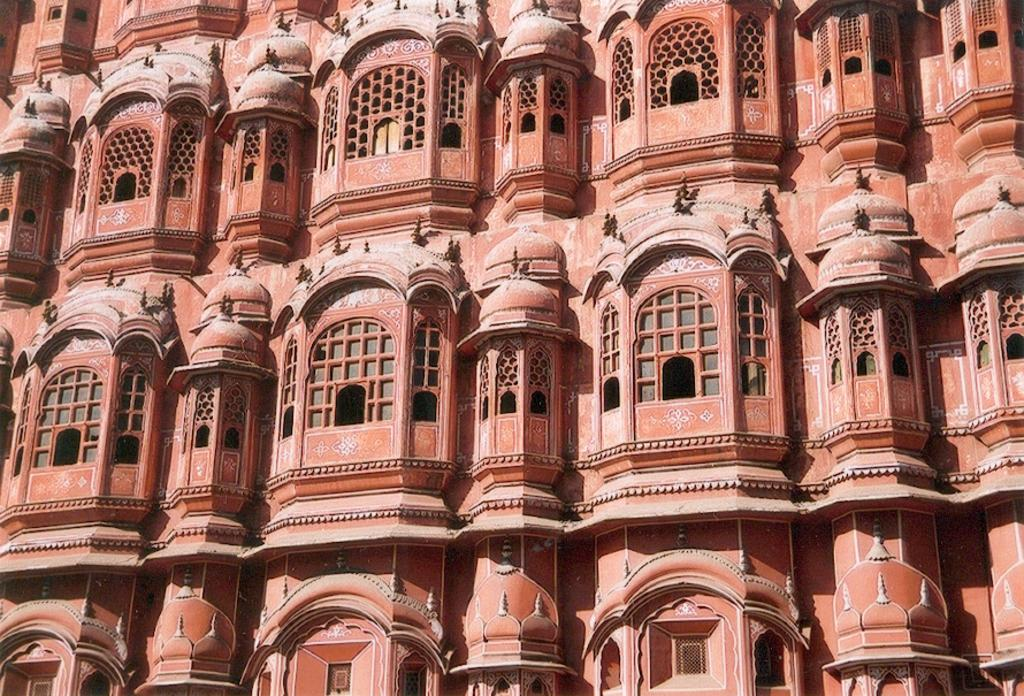What type of structure is present in the image? There is a building in the image. What feature can be seen on the building? The building has windows. How many beds are visible in the image? There are no beds present in the image; it features a building with windows. What type of organization is depicted in the image? There is no organization depicted in the image; it features a building with windows. 